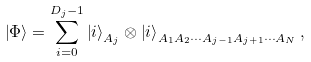<formula> <loc_0><loc_0><loc_500><loc_500>\left | \Phi \right \rangle = \sum _ { i = 0 } ^ { D _ { j } - 1 } \left | i \right \rangle _ { A _ { j } } \otimes \left | i \right \rangle _ { { A _ { 1 } } { A _ { 2 } } \cdots { A _ { j - 1 } } { A _ { j + 1 } } \cdots { A _ { N } } } ,</formula> 